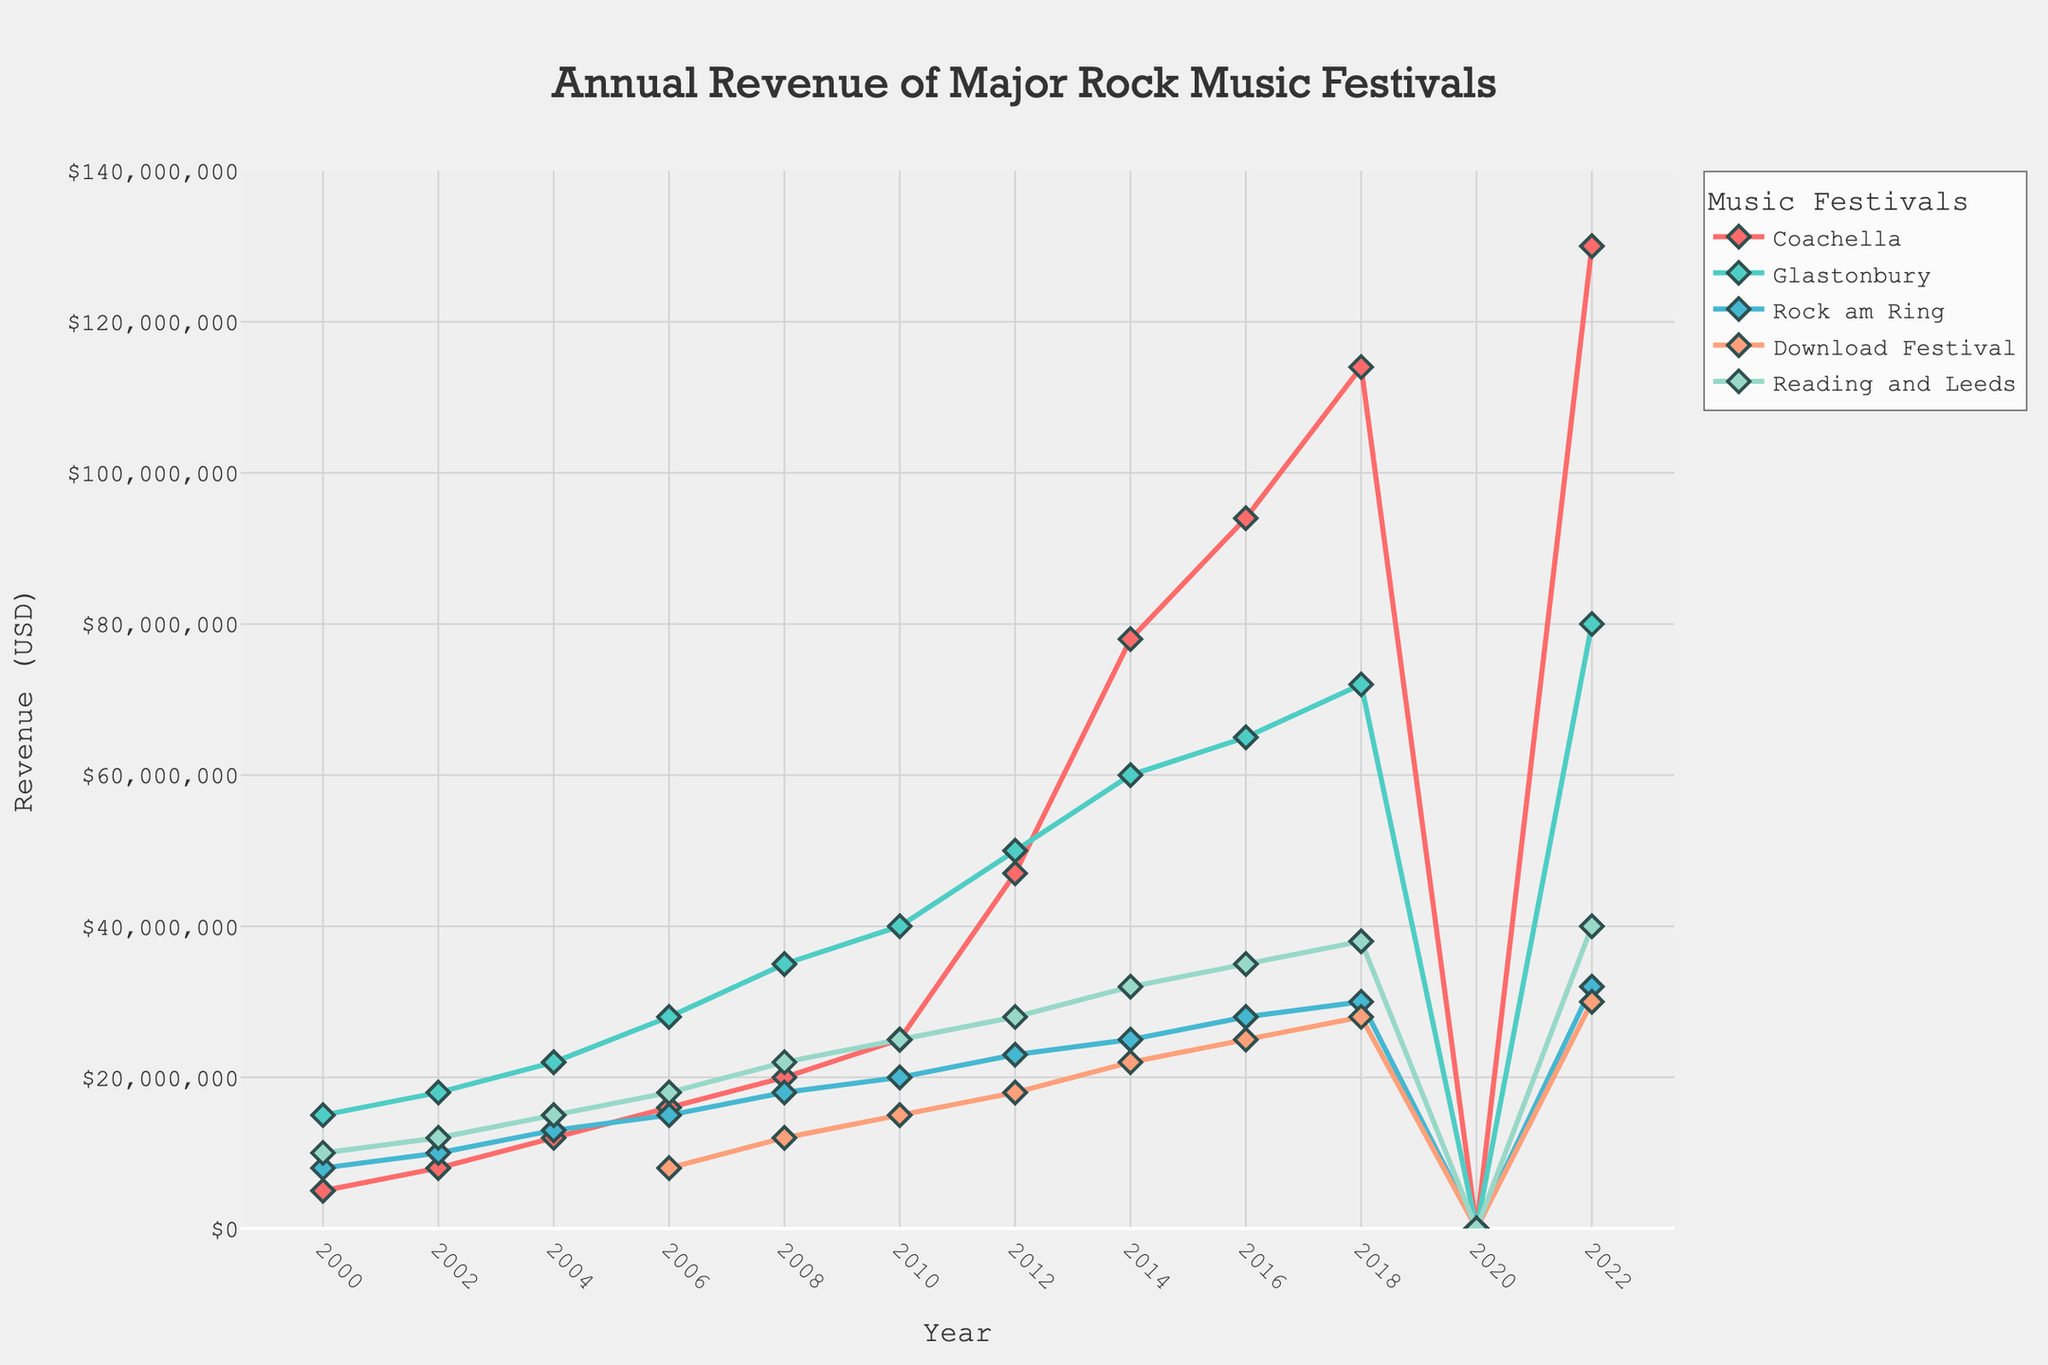What year did Coachella's revenue surpass $50 million for the first time? Observe the Coachella line and find the first year when its revenue exceeds $50 million, which is in 2012.
Answer: 2012 Which festival had the highest revenue in 2022? Compare the revenue values for all festivals in the year 2022. Coachella has the highest at $130 million.
Answer: Coachella Did Reading and Leeds have a higher revenue than Rock am Ring in 2008? Check the revenues of both festivals for 2008: Reading and Leeds had $22 million, while Rock am Ring had $18 million.
Answer: Yes What was the total revenue for all festivals combined in 2018? Sum the revenues for all festivals in 2018: 114,000,000 (Coachella) + 72,000,000 (Glastonbury) + 30,000,000 (Rock am Ring) + 28,000,000 (Download Festival) + 38,000,000 (Reading and Leeds) which equals 282,000,000.
Answer: 282,000,000 Which festival experienced the largest drop in revenue from 2012 to 2014? Compare the revenue changes for all festivals from 2012 to 2014. Glastonbury revenue increased by $10 million, Reading and Leeds increased by $4 million, Coachella increased by $31 million, Download Festival increased by $4 million, and Rock am Ring increased by only $2 million, which means none experienced a drop.
Answer: None What's the average annual revenue of Download Festival from 2014 to 2022? Average the revenues of Download Festival from the years 2014, 2016, 2018, and 2022, which are 22,000,000 + 25,000,000 + 28,000,000 + 30,000,000. The total is 105,000,000, and there are 4 years, so the average is 105,000,000 / 4 = 26,250,000.
Answer: 26,250,000 How did Glastonbury’s revenue in 2018 compare to its revenue in 2010? Compare Glastonbury's revenue in 2018 (72,000,000) and 2010 (40,000,000). The revenue in 2018 is higher by 32,000,000.
Answer: Increased by 32,000,000 Describe the trend in Coachella's revenue from 2006 to 2022. Observe the Coachella trend. The revenue increases steadily from $16 million in 2006 to $130 million in 2022, with a significant drop to $0 in 2020 likely due to the pandemic.
Answer: Steady increase with a drop in 2020 By how much did the revenue of Reading and Leeds increase between 2004 and 2008? The revenue in 2004 was $15 million and in 2008 was $22 million, showing an increase of $7 million.
Answer: 7 million 